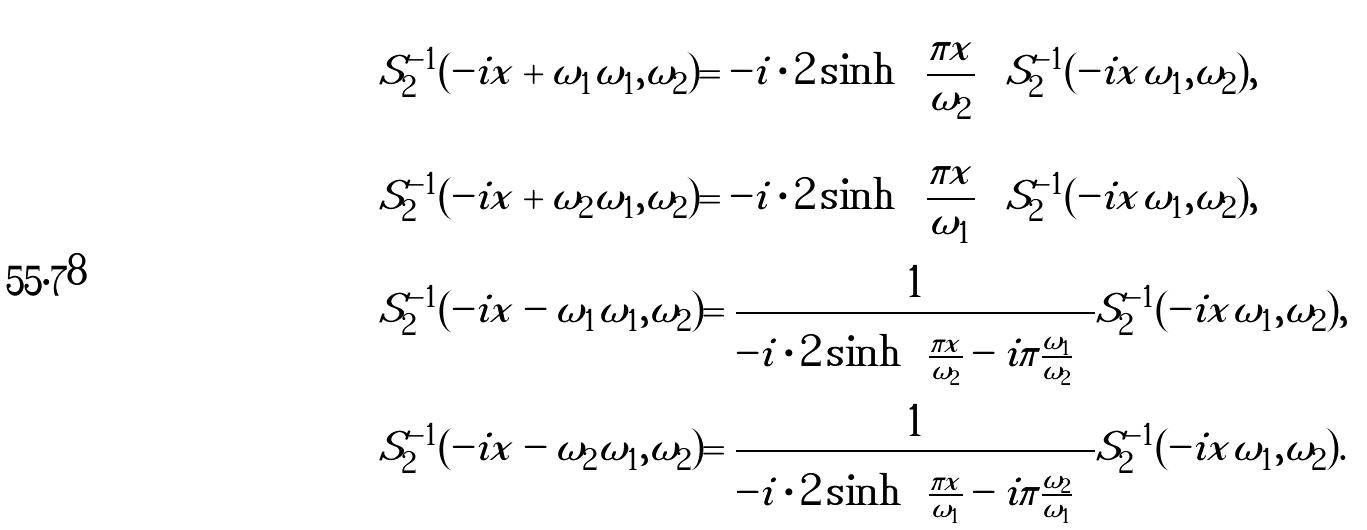<formula> <loc_0><loc_0><loc_500><loc_500>& S _ { 2 } ^ { - 1 } ( - i x + \omega _ { 1 } | \omega _ { 1 } , \omega _ { 2 } ) = - i \cdot 2 \sinh \left [ \frac { \pi x } { \omega _ { 2 } } \right ] S _ { 2 } ^ { - 1 } ( - i x | \omega _ { 1 } , \omega _ { 2 } ) , \\ & S _ { 2 } ^ { - 1 } ( - i x + \omega _ { 2 } | \omega _ { 1 } , \omega _ { 2 } ) = - i \cdot 2 \sinh \left [ \frac { \pi x } { \omega _ { 1 } } \right ] S _ { 2 } ^ { - 1 } ( - i x | \omega _ { 1 } , \omega _ { 2 } ) , \\ & S _ { 2 } ^ { - 1 } ( - i x - \omega _ { 1 } | \omega _ { 1 } , \omega _ { 2 } ) = \frac { 1 } { - i \cdot 2 \sinh \left [ \frac { \pi x } { \omega _ { 2 } } - i \pi \frac { \omega _ { 1 } } { \omega _ { 2 } } \right ] } S _ { 2 } ^ { - 1 } ( - i x | \omega _ { 1 } , \omega _ { 2 } ) , \\ & S _ { 2 } ^ { - 1 } ( - i x - \omega _ { 2 } | \omega _ { 1 } , \omega _ { 2 } ) = \frac { 1 } { - i \cdot 2 \sinh \left [ \frac { \pi x } { \omega _ { 1 } } - i \pi \frac { \omega _ { 2 } } { \omega _ { 1 } } \right ] } S _ { 2 } ^ { - 1 } ( - i x | \omega _ { 1 } , \omega _ { 2 } ) .</formula> 